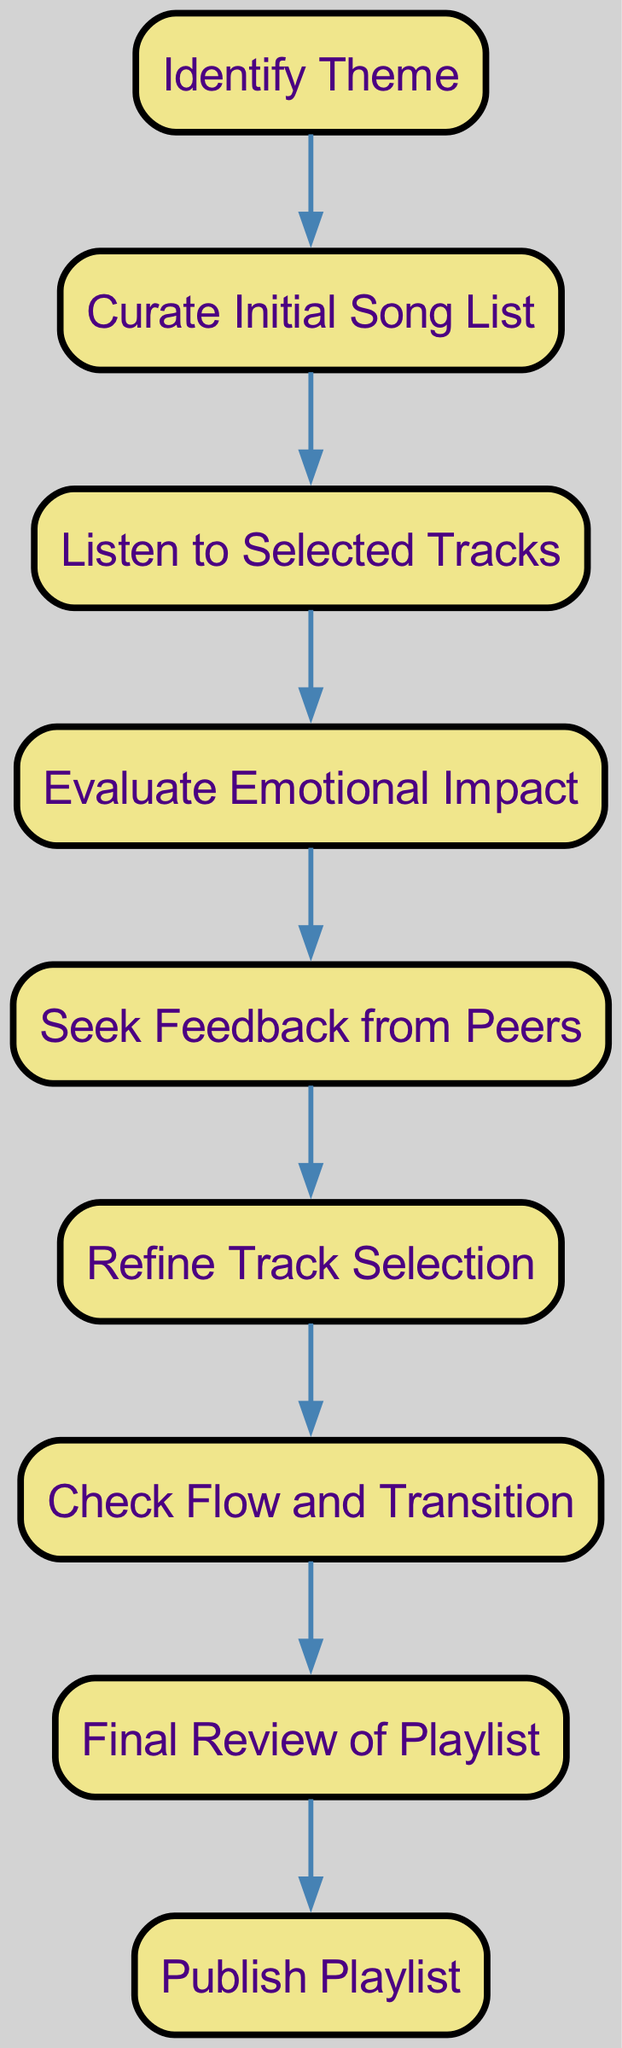What is the first step in the playlist curation process? The diagram indicates that the first step is "Identify Theme", which is the starting point before any other actions are taken in the process.
Answer: Identify Theme How many nodes are in the diagram? By counting each unique step represented in the diagram, we find there are a total of 9 nodes involved in the playlist curation process.
Answer: 9 What follows the "Listen to Selected Tracks" step? Observing the flow from the diagram, the step that directly follows "Listen to Selected Tracks" is "Evaluate Emotional Impact", indicating a continuous progression in the process.
Answer: Evaluate Emotional Impact Which node comes before "Refine Track Selection"? The diagram shows that "Seek Feedback from Peers" is the step that comes directly before "Refine Track Selection", indicating the importance of peer feedback in this process.
Answer: Seek Feedback from Peers What is the final step in the playlist curation process? According to the directed graph, the last step in the playlist curation process is "Publish Playlist", which is the culmination of all previous steps.
Answer: Publish Playlist How many edges are present in the diagram? By examining each connection between the nodes, we can determine that there are 8 edges depicted in the diagram, representing the flow of the process.
Answer: 8 What is the relationship between "Check Flow and Transition" and "Final Review of Playlist"? The diagram shows a direct connection where "Check Flow and Transition" leads into "Final Review of Playlist", indicating that the flow of the playlist is assessed before the final review is conducted.
Answer: Direct connection What occurs after "Evaluate Emotional Impact"? Following "Evaluate Emotional Impact", the next step in the process, as shown in the diagram, is "Seek Feedback from Peers", highlighting the collaborative nature of playlist curation.
Answer: Seek Feedback from Peers 